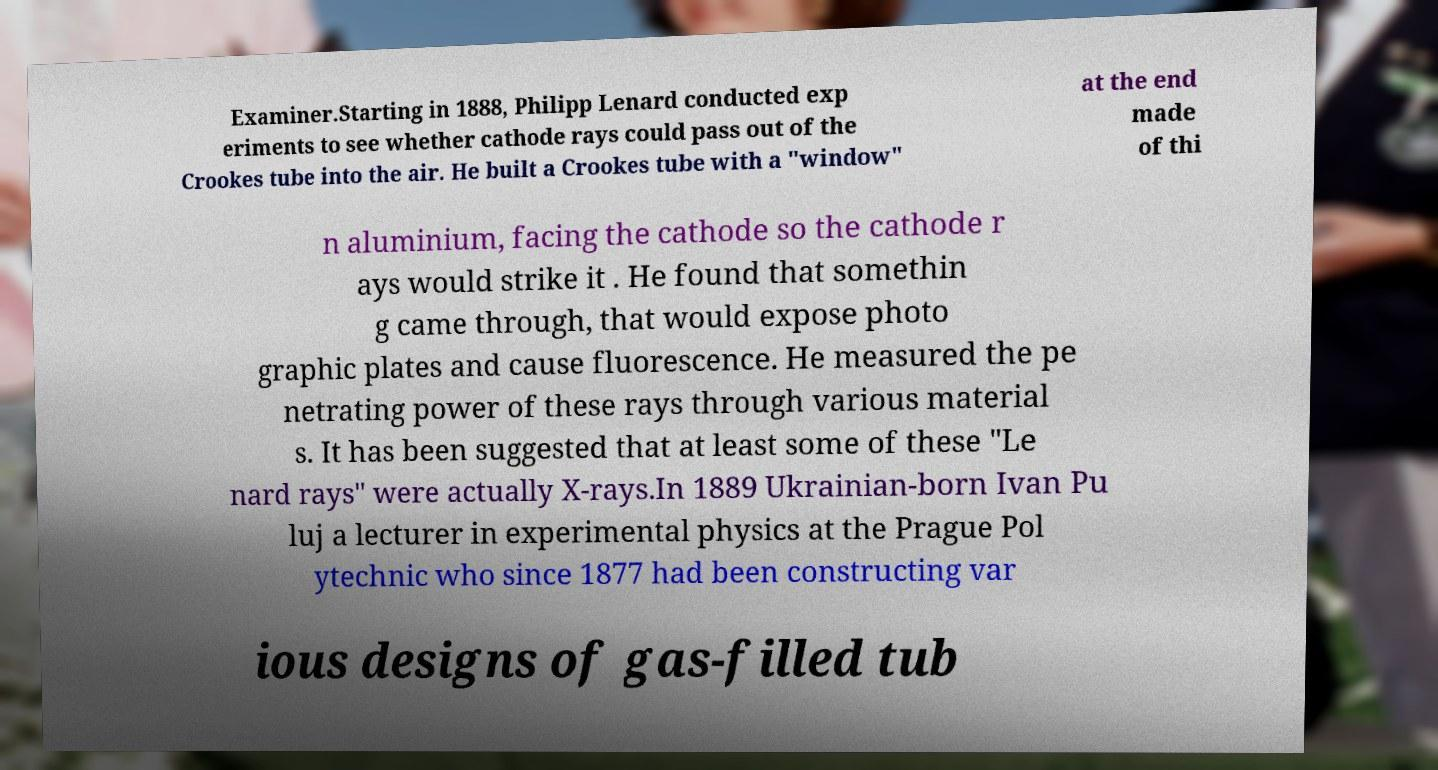Please identify and transcribe the text found in this image. Examiner.Starting in 1888, Philipp Lenard conducted exp eriments to see whether cathode rays could pass out of the Crookes tube into the air. He built a Crookes tube with a "window" at the end made of thi n aluminium, facing the cathode so the cathode r ays would strike it . He found that somethin g came through, that would expose photo graphic plates and cause fluorescence. He measured the pe netrating power of these rays through various material s. It has been suggested that at least some of these "Le nard rays" were actually X-rays.In 1889 Ukrainian-born Ivan Pu luj a lecturer in experimental physics at the Prague Pol ytechnic who since 1877 had been constructing var ious designs of gas-filled tub 